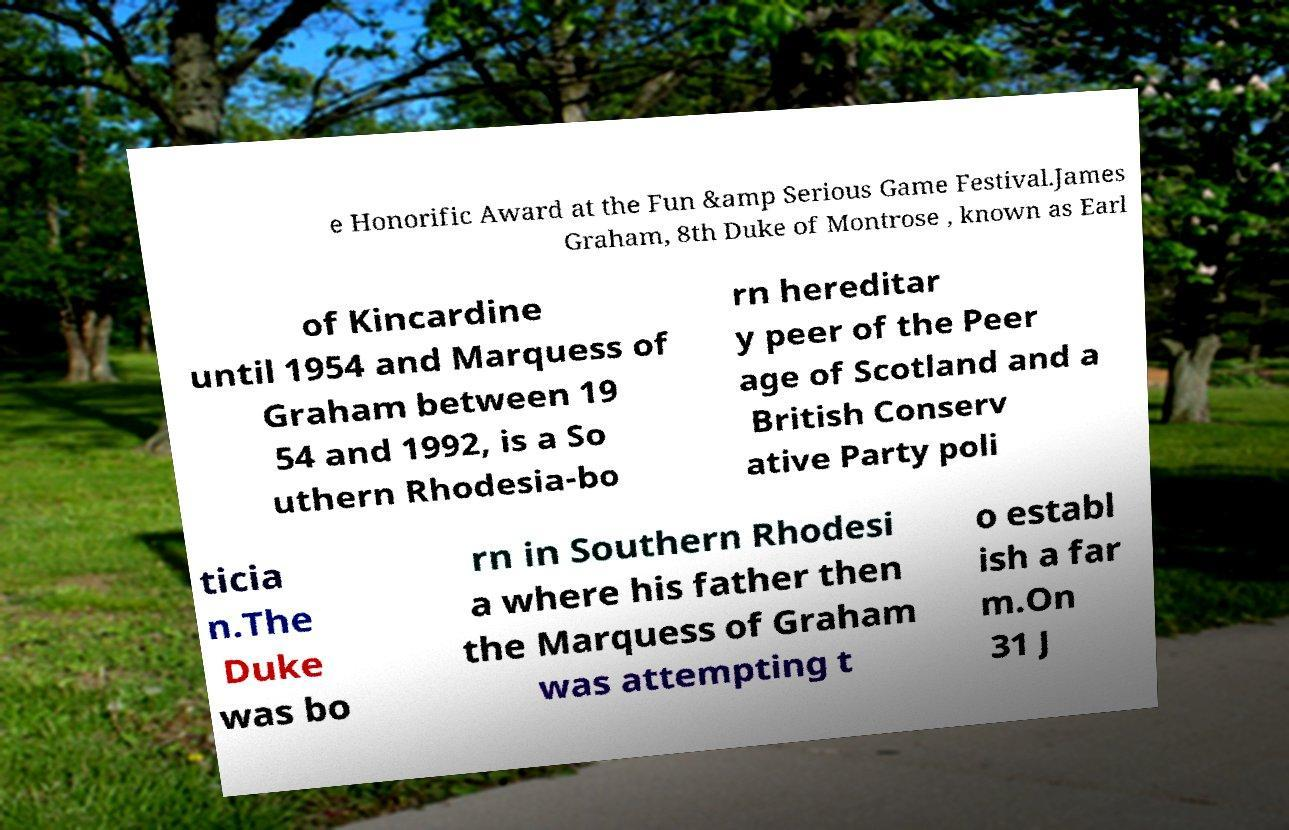Can you read and provide the text displayed in the image?This photo seems to have some interesting text. Can you extract and type it out for me? e Honorific Award at the Fun &amp Serious Game Festival.James Graham, 8th Duke of Montrose , known as Earl of Kincardine until 1954 and Marquess of Graham between 19 54 and 1992, is a So uthern Rhodesia-bo rn hereditar y peer of the Peer age of Scotland and a British Conserv ative Party poli ticia n.The Duke was bo rn in Southern Rhodesi a where his father then the Marquess of Graham was attempting t o establ ish a far m.On 31 J 